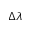Convert formula to latex. <formula><loc_0><loc_0><loc_500><loc_500>\Delta \lambda</formula> 